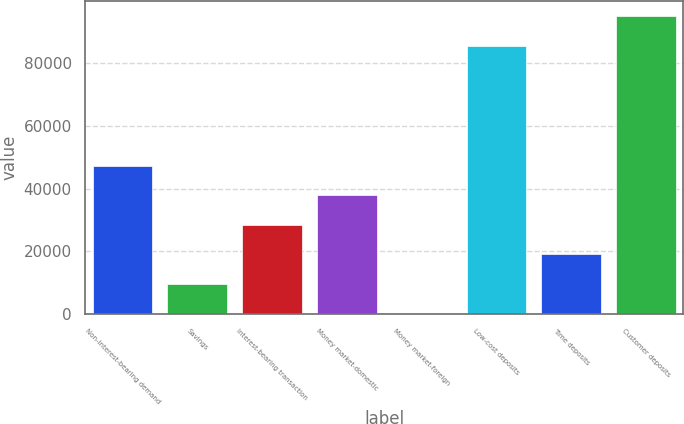<chart> <loc_0><loc_0><loc_500><loc_500><bar_chart><fcel>Non-interest-bearing demand<fcel>Savings<fcel>Interest-bearing transaction<fcel>Money market-domestic<fcel>Money market-foreign<fcel>Low-cost deposits<fcel>Time deposits<fcel>Customer deposits<nl><fcel>47232.5<fcel>9658.5<fcel>28445.5<fcel>37839<fcel>265<fcel>85605<fcel>19052<fcel>94998.5<nl></chart> 